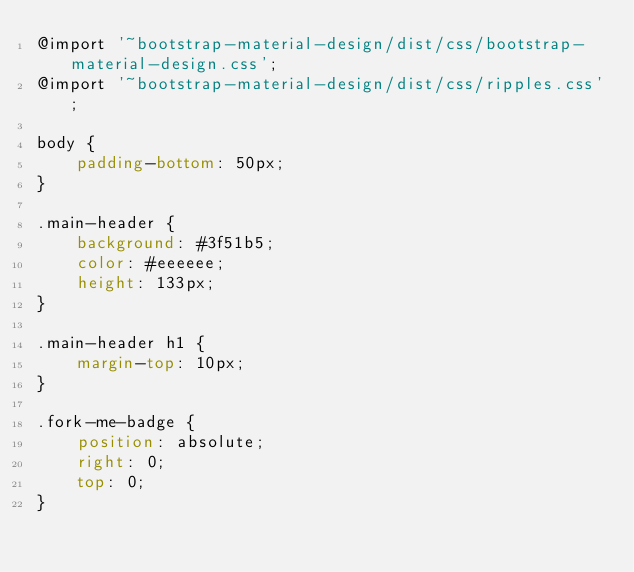Convert code to text. <code><loc_0><loc_0><loc_500><loc_500><_CSS_>@import '~bootstrap-material-design/dist/css/bootstrap-material-design.css';
@import '~bootstrap-material-design/dist/css/ripples.css';

body {
    padding-bottom: 50px;
}

.main-header {
    background: #3f51b5;
    color: #eeeeee;
    height: 133px;
}

.main-header h1 {
    margin-top: 10px;
}

.fork-me-badge {
    position: absolute;
    right: 0;
    top: 0;
}</code> 